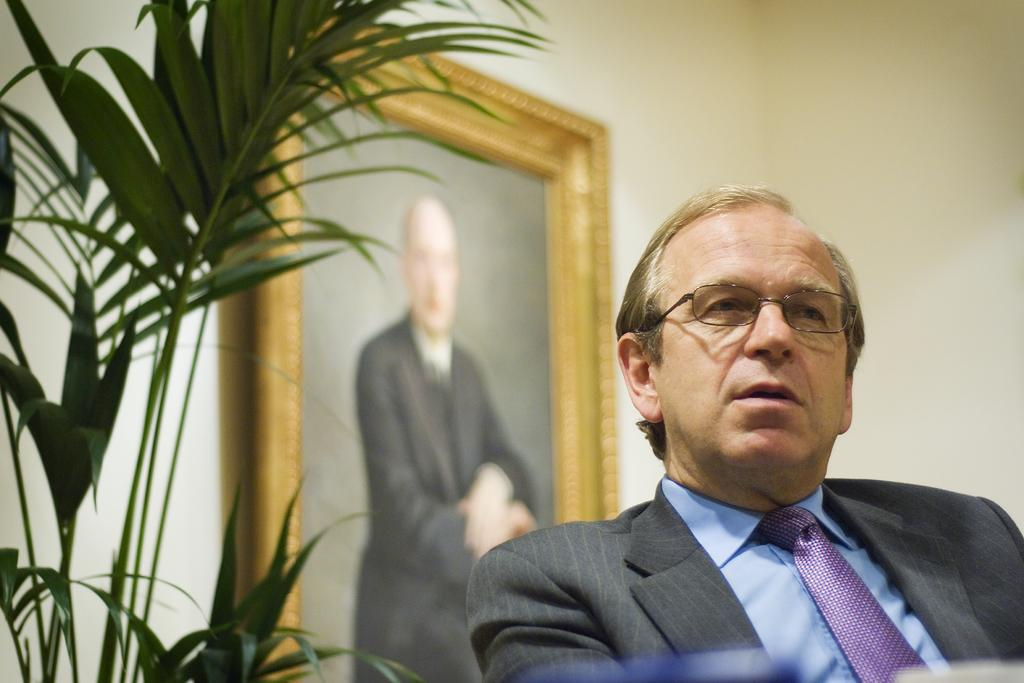Who is present in the image? There is a man in the image. Where is the man located in the image? The man is on the right side of the image. What is the man wearing in the image? The man is wearing a suit and a tie. What type of vegetation can be seen in the image? There is a plant in the image. Where is the plant located in the image? The plant is on the left side of the image. What can be seen in the background of the image? There is a photo frame in the background of the image. What type of train can be seen in the image? There is no train present in the image. What brand of toothpaste is the man using in the image? There is no toothpaste visible in the image, and the man's personal hygiene habits are not mentioned. 